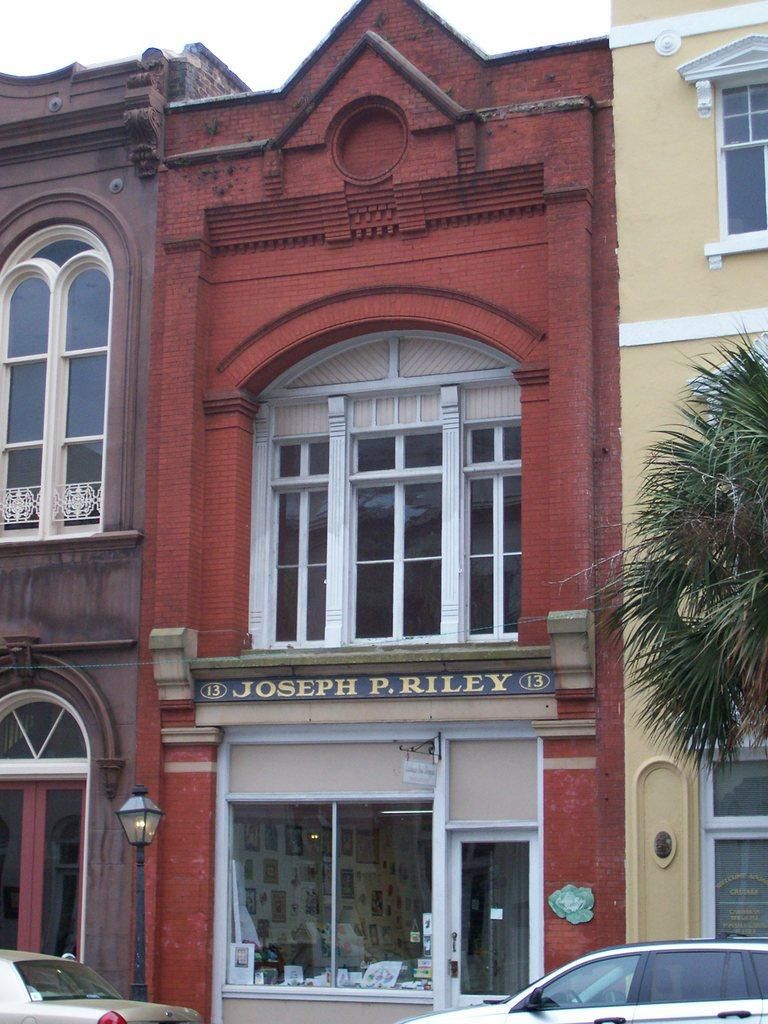What type of structures can be seen in the image? There are buildings in the image. What is located on the right side of the image? There are trees on the right side of the image. What type of vehicles are at the bottom of the image? There are cars at the bottom of the image. What can be seen in the background of the image? The sky is visible in the background of the image, and there is also a pole. What type of notebook is being used by the ray in the image? There is no ray or notebook present in the image. 